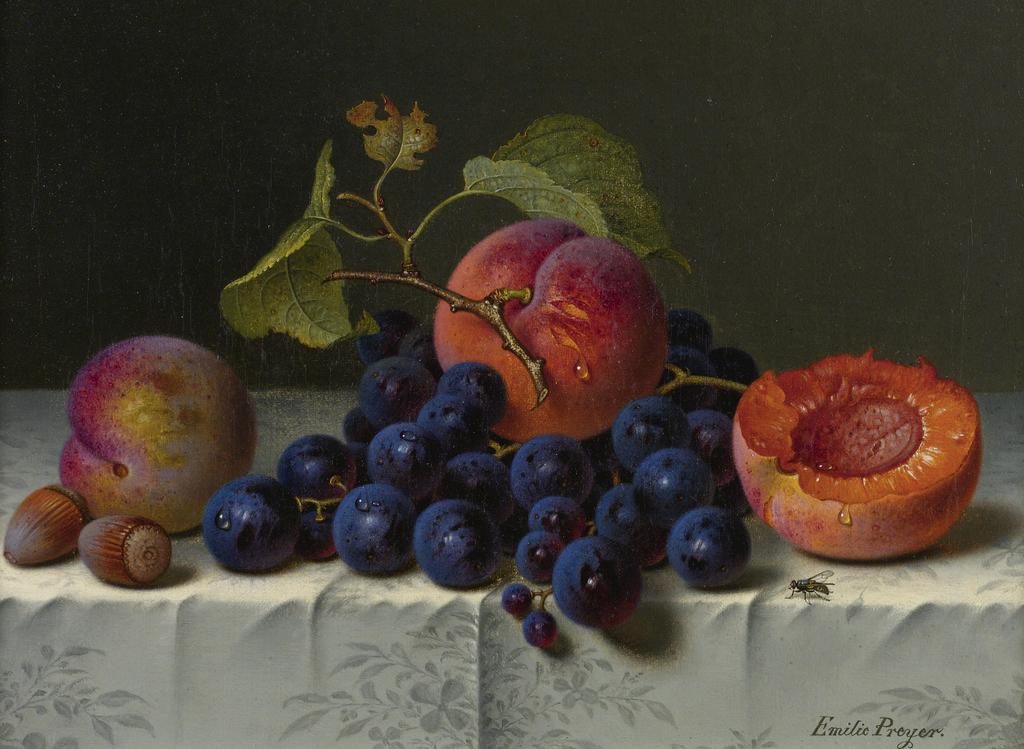Describe this image in one or two sentences. In this image we can see a group of fruits on a cloth. On the right side, we can see a housefly. In the bottom right we can see some text. Behind the fruits we can see the gray background. 